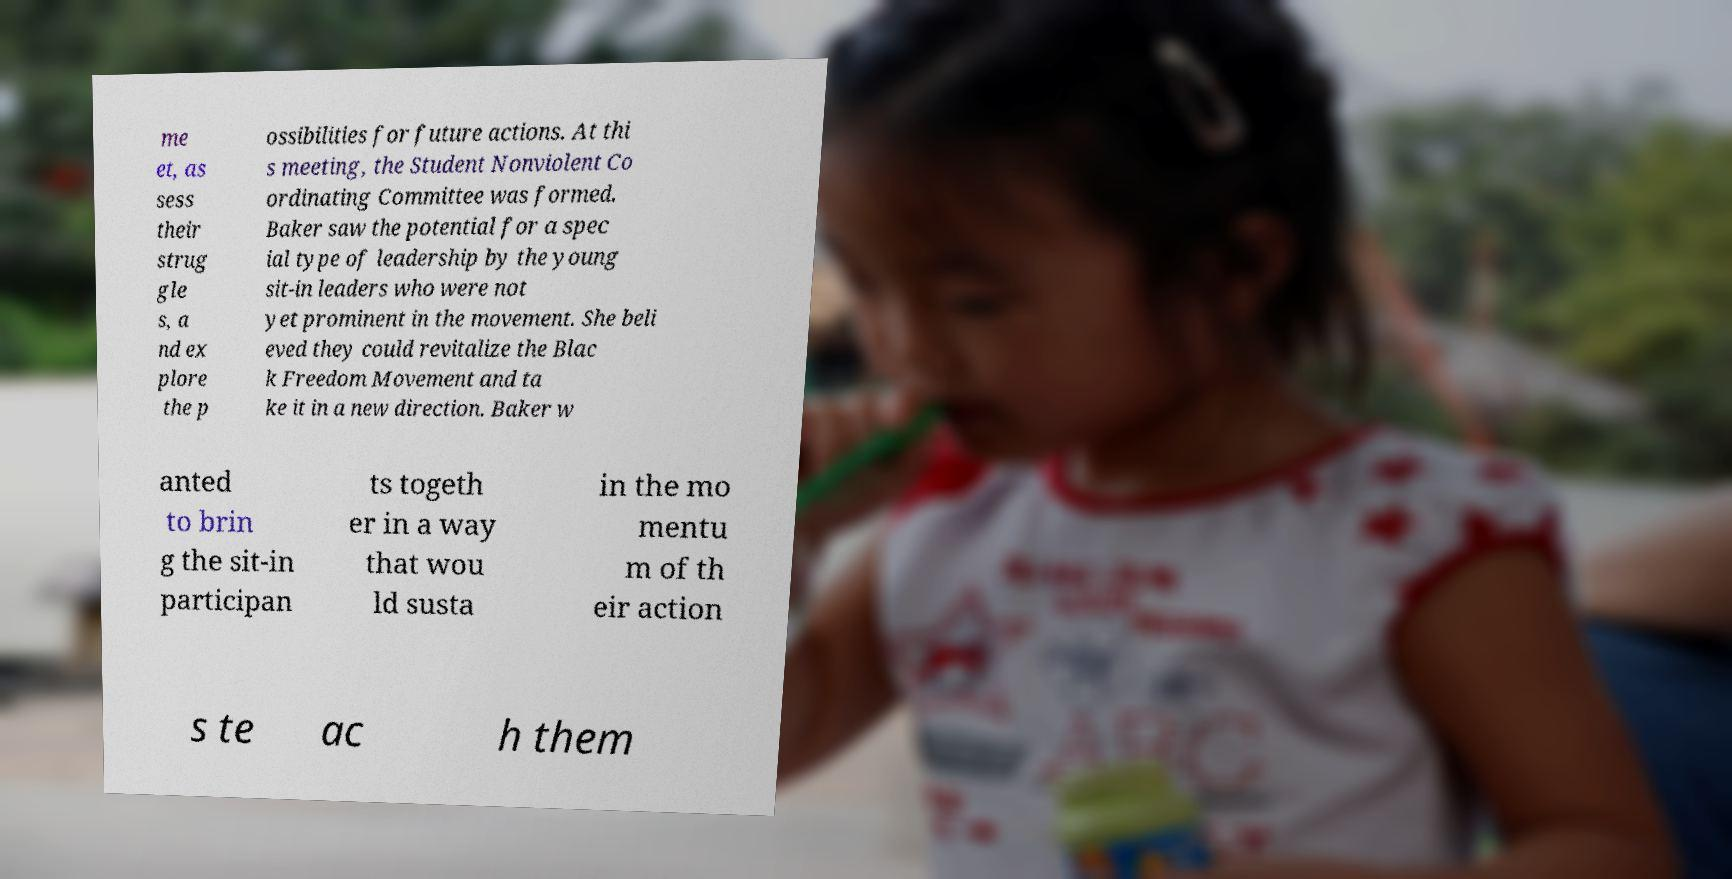Please read and relay the text visible in this image. What does it say? me et, as sess their strug gle s, a nd ex plore the p ossibilities for future actions. At thi s meeting, the Student Nonviolent Co ordinating Committee was formed. Baker saw the potential for a spec ial type of leadership by the young sit-in leaders who were not yet prominent in the movement. She beli eved they could revitalize the Blac k Freedom Movement and ta ke it in a new direction. Baker w anted to brin g the sit-in participan ts togeth er in a way that wou ld susta in the mo mentu m of th eir action s te ac h them 